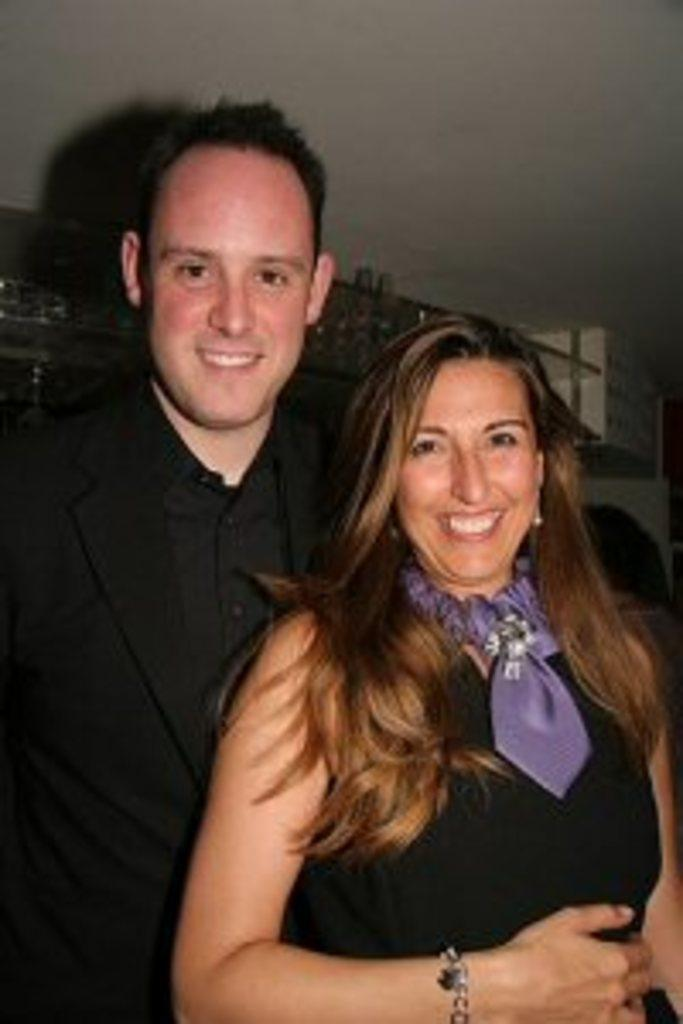How many people are in the image? There are two people in the image. What are the two people doing in the image? The two people are standing and posing for a photo. Where is the snail located in the image? There is no snail present in the image. What type of fairies can be seen flying around the two people in the image? There are no fairies present in the image; it only features two people standing and posing for a photo. 